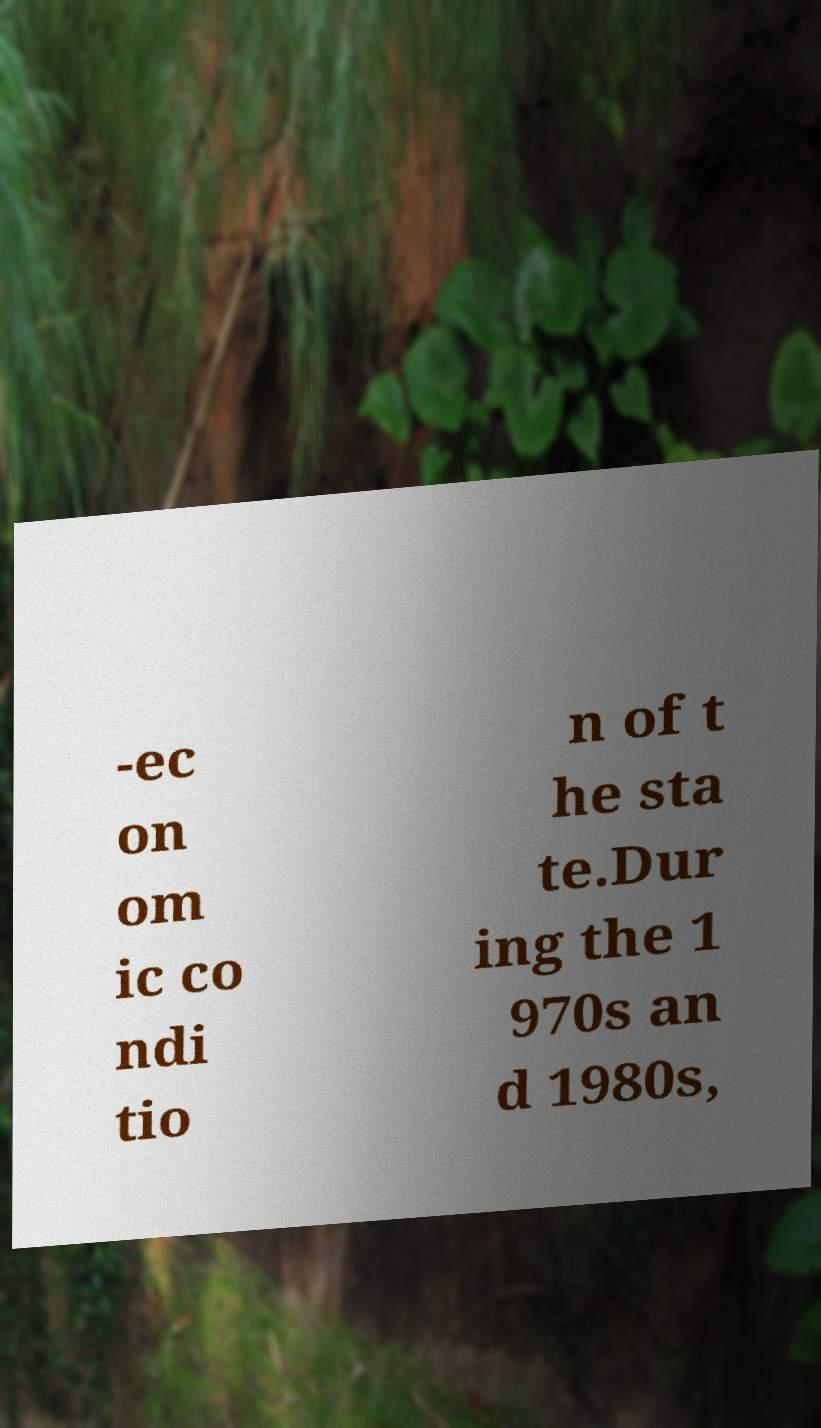Please read and relay the text visible in this image. What does it say? -ec on om ic co ndi tio n of t he sta te.Dur ing the 1 970s an d 1980s, 